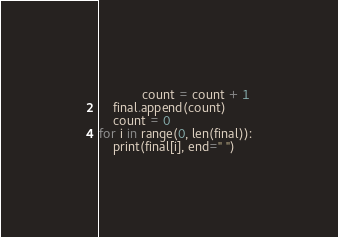Convert code to text. <code><loc_0><loc_0><loc_500><loc_500><_Python_>            count = count + 1
    final.append(count)
    count = 0
for i in range(0, len(final)):
    print(final[i], end=" ")</code> 